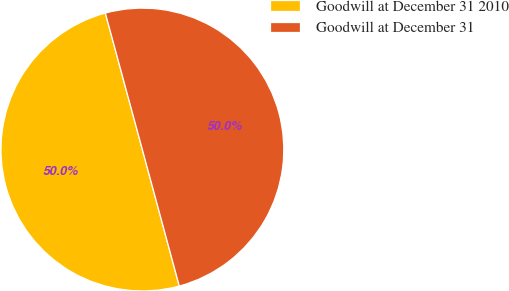Convert chart to OTSL. <chart><loc_0><loc_0><loc_500><loc_500><pie_chart><fcel>Goodwill at December 31 2010<fcel>Goodwill at December 31<nl><fcel>49.99%<fcel>50.01%<nl></chart> 